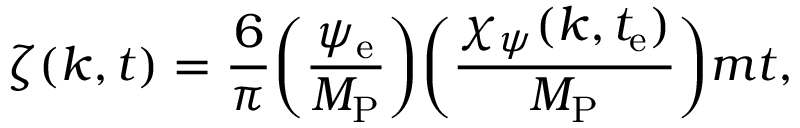Convert formula to latex. <formula><loc_0><loc_0><loc_500><loc_500>\zeta ( k , t ) = \frac { 6 } { \pi } \left ( \frac { \psi _ { e } } { M _ { P } } \right ) \left ( \frac { \chi _ { \psi } ( k , t _ { e } ) } { M _ { P } } \right ) m t ,</formula> 